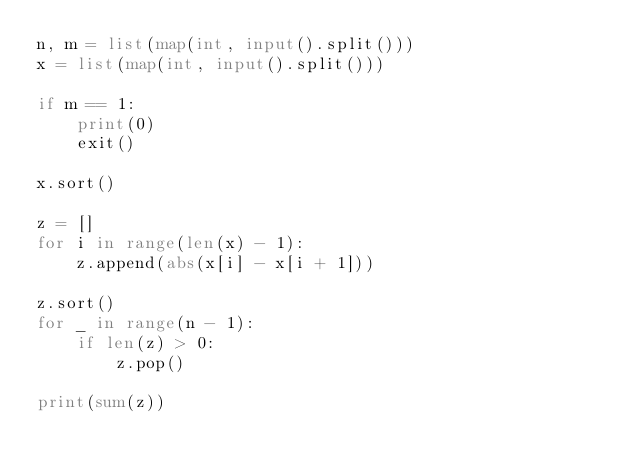<code> <loc_0><loc_0><loc_500><loc_500><_Python_>n, m = list(map(int, input().split()))
x = list(map(int, input().split()))

if m == 1:
    print(0)
    exit()

x.sort()

z = []
for i in range(len(x) - 1):
    z.append(abs(x[i] - x[i + 1]))

z.sort()
for _ in range(n - 1):
    if len(z) > 0:
        z.pop()

print(sum(z))</code> 